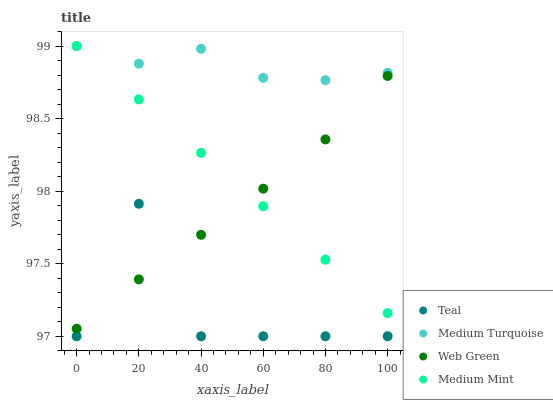Does Teal have the minimum area under the curve?
Answer yes or no. Yes. Does Medium Turquoise have the maximum area under the curve?
Answer yes or no. Yes. Does Web Green have the minimum area under the curve?
Answer yes or no. No. Does Web Green have the maximum area under the curve?
Answer yes or no. No. Is Medium Mint the smoothest?
Answer yes or no. Yes. Is Teal the roughest?
Answer yes or no. Yes. Is Web Green the smoothest?
Answer yes or no. No. Is Web Green the roughest?
Answer yes or no. No. Does Teal have the lowest value?
Answer yes or no. Yes. Does Web Green have the lowest value?
Answer yes or no. No. Does Medium Turquoise have the highest value?
Answer yes or no. Yes. Does Web Green have the highest value?
Answer yes or no. No. Is Teal less than Medium Mint?
Answer yes or no. Yes. Is Medium Turquoise greater than Web Green?
Answer yes or no. Yes. Does Teal intersect Web Green?
Answer yes or no. Yes. Is Teal less than Web Green?
Answer yes or no. No. Is Teal greater than Web Green?
Answer yes or no. No. Does Teal intersect Medium Mint?
Answer yes or no. No. 